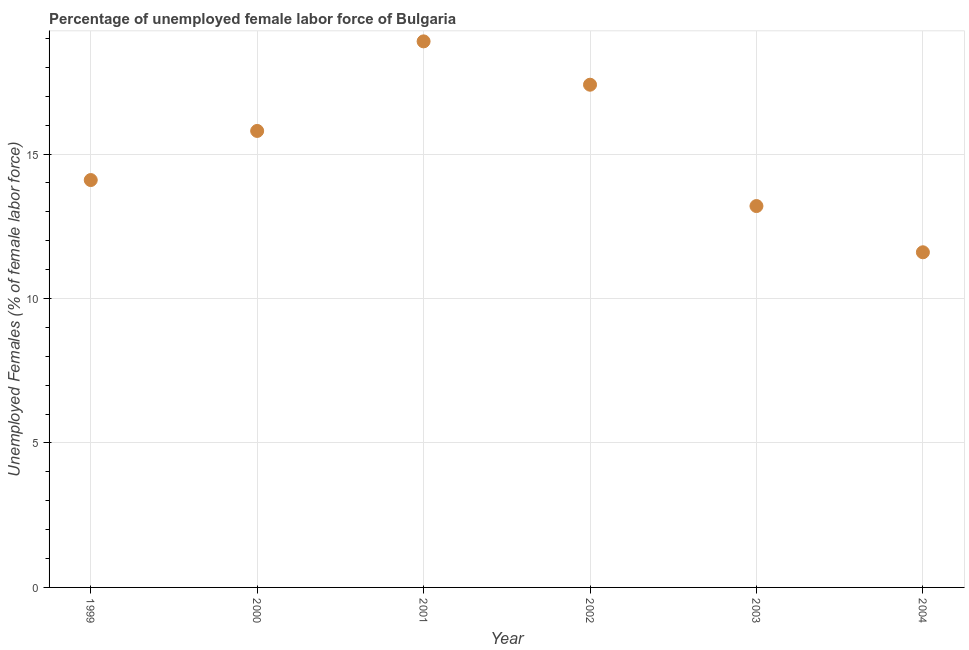What is the total unemployed female labour force in 1999?
Offer a very short reply. 14.1. Across all years, what is the maximum total unemployed female labour force?
Make the answer very short. 18.9. Across all years, what is the minimum total unemployed female labour force?
Ensure brevity in your answer.  11.6. What is the sum of the total unemployed female labour force?
Provide a short and direct response. 91. What is the difference between the total unemployed female labour force in 2001 and 2003?
Give a very brief answer. 5.7. What is the average total unemployed female labour force per year?
Keep it short and to the point. 15.17. What is the median total unemployed female labour force?
Give a very brief answer. 14.95. In how many years, is the total unemployed female labour force greater than 17 %?
Your answer should be very brief. 2. Do a majority of the years between 2004 and 2000 (inclusive) have total unemployed female labour force greater than 8 %?
Your answer should be compact. Yes. What is the ratio of the total unemployed female labour force in 2002 to that in 2004?
Your answer should be very brief. 1.5. Is the sum of the total unemployed female labour force in 1999 and 2003 greater than the maximum total unemployed female labour force across all years?
Make the answer very short. Yes. What is the difference between the highest and the lowest total unemployed female labour force?
Make the answer very short. 7.3. In how many years, is the total unemployed female labour force greater than the average total unemployed female labour force taken over all years?
Your answer should be compact. 3. Does the total unemployed female labour force monotonically increase over the years?
Provide a short and direct response. No. How many dotlines are there?
Give a very brief answer. 1. What is the difference between two consecutive major ticks on the Y-axis?
Keep it short and to the point. 5. Does the graph contain any zero values?
Keep it short and to the point. No. Does the graph contain grids?
Provide a short and direct response. Yes. What is the title of the graph?
Offer a very short reply. Percentage of unemployed female labor force of Bulgaria. What is the label or title of the X-axis?
Your response must be concise. Year. What is the label or title of the Y-axis?
Provide a succinct answer. Unemployed Females (% of female labor force). What is the Unemployed Females (% of female labor force) in 1999?
Your answer should be very brief. 14.1. What is the Unemployed Females (% of female labor force) in 2000?
Your answer should be very brief. 15.8. What is the Unemployed Females (% of female labor force) in 2001?
Keep it short and to the point. 18.9. What is the Unemployed Females (% of female labor force) in 2002?
Give a very brief answer. 17.4. What is the Unemployed Females (% of female labor force) in 2003?
Keep it short and to the point. 13.2. What is the Unemployed Females (% of female labor force) in 2004?
Make the answer very short. 11.6. What is the difference between the Unemployed Females (% of female labor force) in 1999 and 2001?
Your answer should be very brief. -4.8. What is the difference between the Unemployed Females (% of female labor force) in 1999 and 2002?
Offer a very short reply. -3.3. What is the difference between the Unemployed Females (% of female labor force) in 1999 and 2003?
Give a very brief answer. 0.9. What is the difference between the Unemployed Females (% of female labor force) in 2000 and 2002?
Give a very brief answer. -1.6. What is the difference between the Unemployed Females (% of female labor force) in 2000 and 2003?
Provide a succinct answer. 2.6. What is the difference between the Unemployed Females (% of female labor force) in 2001 and 2002?
Give a very brief answer. 1.5. What is the difference between the Unemployed Females (% of female labor force) in 2001 and 2004?
Give a very brief answer. 7.3. What is the difference between the Unemployed Females (% of female labor force) in 2002 and 2004?
Make the answer very short. 5.8. What is the ratio of the Unemployed Females (% of female labor force) in 1999 to that in 2000?
Ensure brevity in your answer.  0.89. What is the ratio of the Unemployed Females (% of female labor force) in 1999 to that in 2001?
Offer a very short reply. 0.75. What is the ratio of the Unemployed Females (% of female labor force) in 1999 to that in 2002?
Keep it short and to the point. 0.81. What is the ratio of the Unemployed Females (% of female labor force) in 1999 to that in 2003?
Ensure brevity in your answer.  1.07. What is the ratio of the Unemployed Females (% of female labor force) in 1999 to that in 2004?
Make the answer very short. 1.22. What is the ratio of the Unemployed Females (% of female labor force) in 2000 to that in 2001?
Keep it short and to the point. 0.84. What is the ratio of the Unemployed Females (% of female labor force) in 2000 to that in 2002?
Ensure brevity in your answer.  0.91. What is the ratio of the Unemployed Females (% of female labor force) in 2000 to that in 2003?
Keep it short and to the point. 1.2. What is the ratio of the Unemployed Females (% of female labor force) in 2000 to that in 2004?
Provide a succinct answer. 1.36. What is the ratio of the Unemployed Females (% of female labor force) in 2001 to that in 2002?
Offer a very short reply. 1.09. What is the ratio of the Unemployed Females (% of female labor force) in 2001 to that in 2003?
Your answer should be very brief. 1.43. What is the ratio of the Unemployed Females (% of female labor force) in 2001 to that in 2004?
Ensure brevity in your answer.  1.63. What is the ratio of the Unemployed Females (% of female labor force) in 2002 to that in 2003?
Your response must be concise. 1.32. What is the ratio of the Unemployed Females (% of female labor force) in 2003 to that in 2004?
Offer a very short reply. 1.14. 